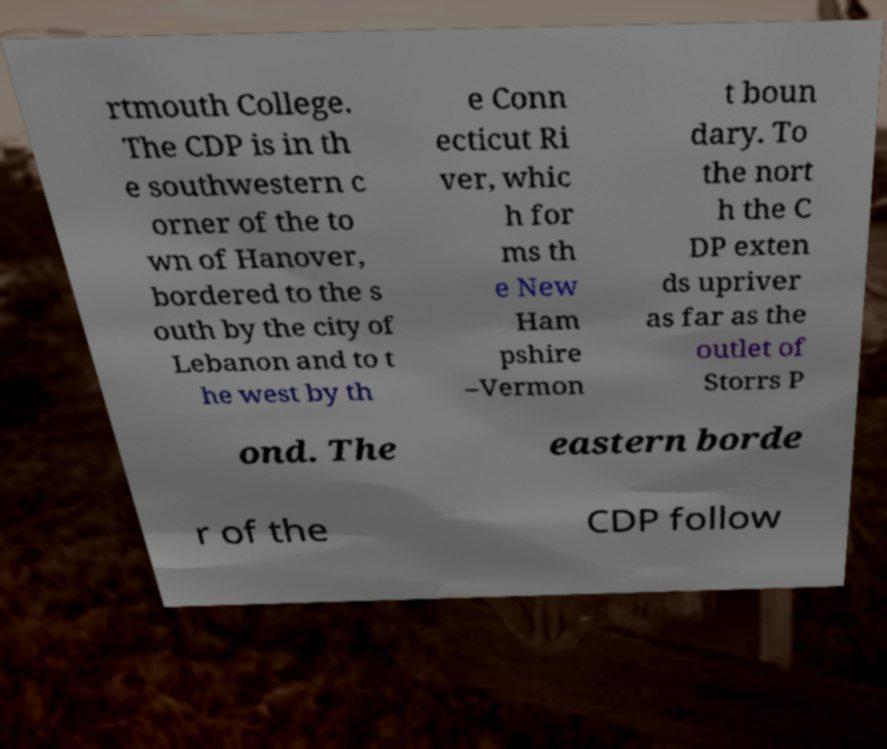There's text embedded in this image that I need extracted. Can you transcribe it verbatim? rtmouth College. The CDP is in th e southwestern c orner of the to wn of Hanover, bordered to the s outh by the city of Lebanon and to t he west by th e Conn ecticut Ri ver, whic h for ms th e New Ham pshire –Vermon t boun dary. To the nort h the C DP exten ds upriver as far as the outlet of Storrs P ond. The eastern borde r of the CDP follow 